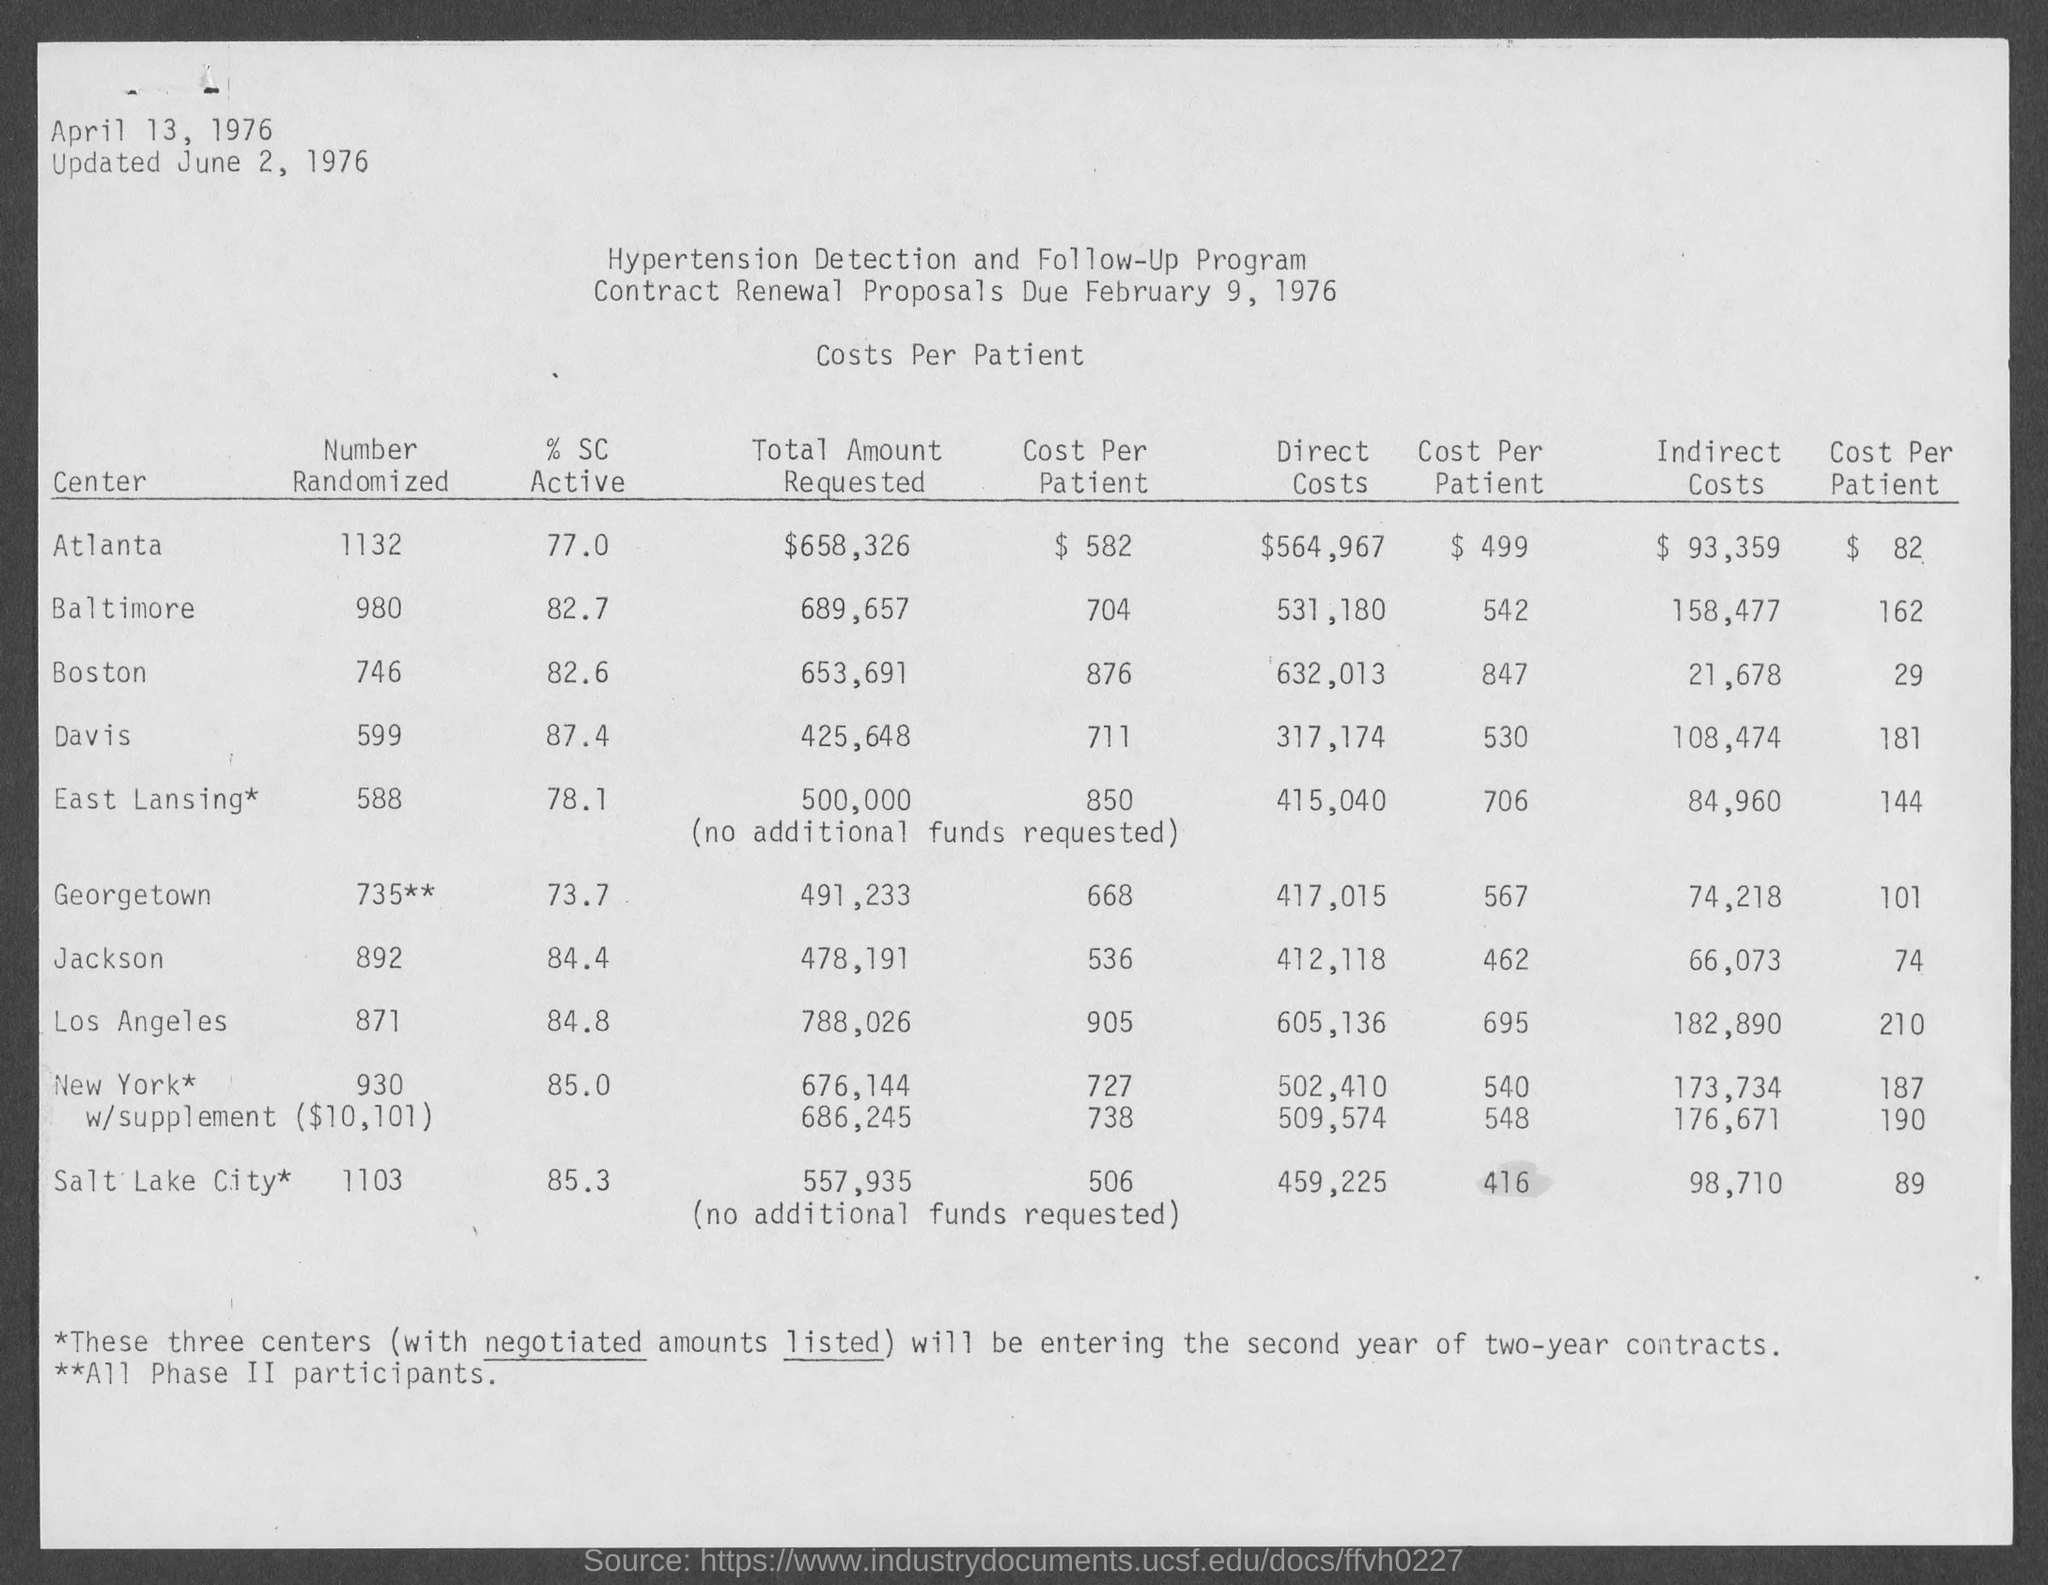Highlight a few significant elements in this photo. The title of the table is 'Costs per patient.' A randomized number has been selected for Atlanta, resulting in the number 1132. The name of the program is the Hypertension Detection and Follow-Up Program. The direct costs for Atlanta are estimated to be $564,967. The indirect costs for Atlanta are estimated to be $93,359. 